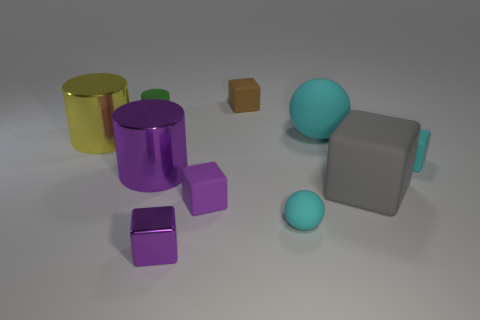The rubber sphere right of the cyan matte object in front of the large purple metal cylinder is what color?
Keep it short and to the point. Cyan. There is a big cube; is it the same color as the cylinder that is behind the large rubber ball?
Give a very brief answer. No. What size is the purple thing that is made of the same material as the green object?
Your answer should be compact. Small. What is the size of the matte object that is the same color as the shiny cube?
Make the answer very short. Small. Does the small shiny thing have the same color as the large block?
Your answer should be compact. No. There is a small purple object in front of the tiny purple thing behind the small metallic cube; is there a tiny matte sphere left of it?
Give a very brief answer. No. What number of brown rubber things have the same size as the green cylinder?
Your answer should be compact. 1. Do the cyan sphere in front of the big purple object and the purple metallic thing that is in front of the big gray block have the same size?
Provide a succinct answer. Yes. There is a large thing that is behind the big gray object and on the right side of the purple cylinder; what is its shape?
Ensure brevity in your answer.  Sphere. Is there another metal thing of the same color as the small shiny object?
Your answer should be compact. Yes. 